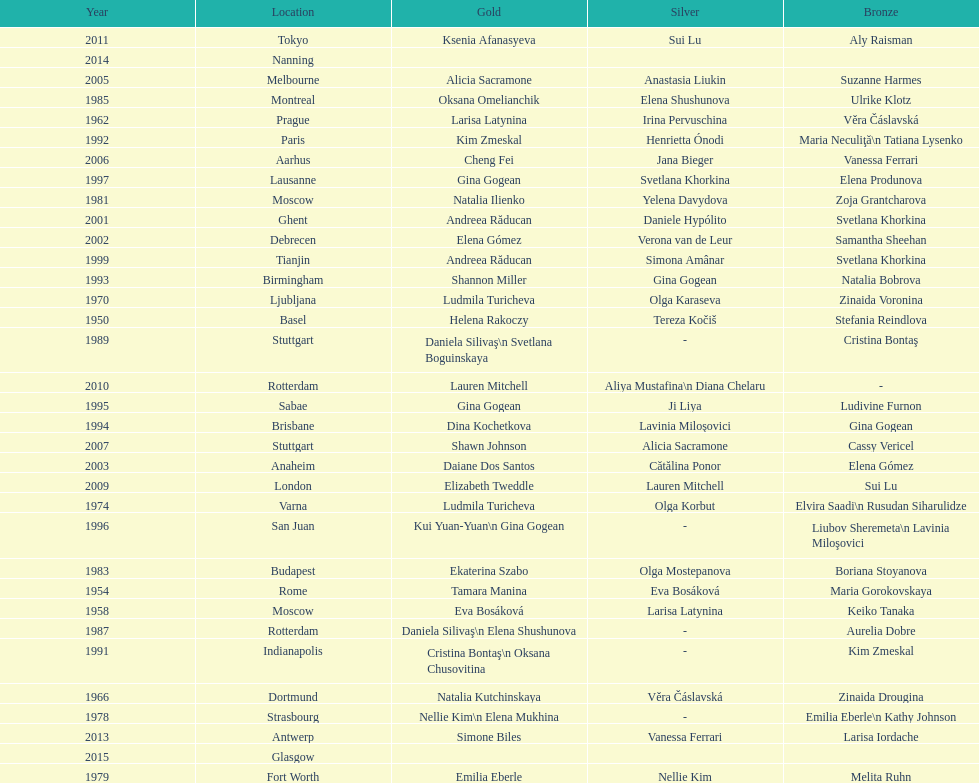As of 2013, what is the total number of floor exercise gold medals won by american women at the world championships? 5. 